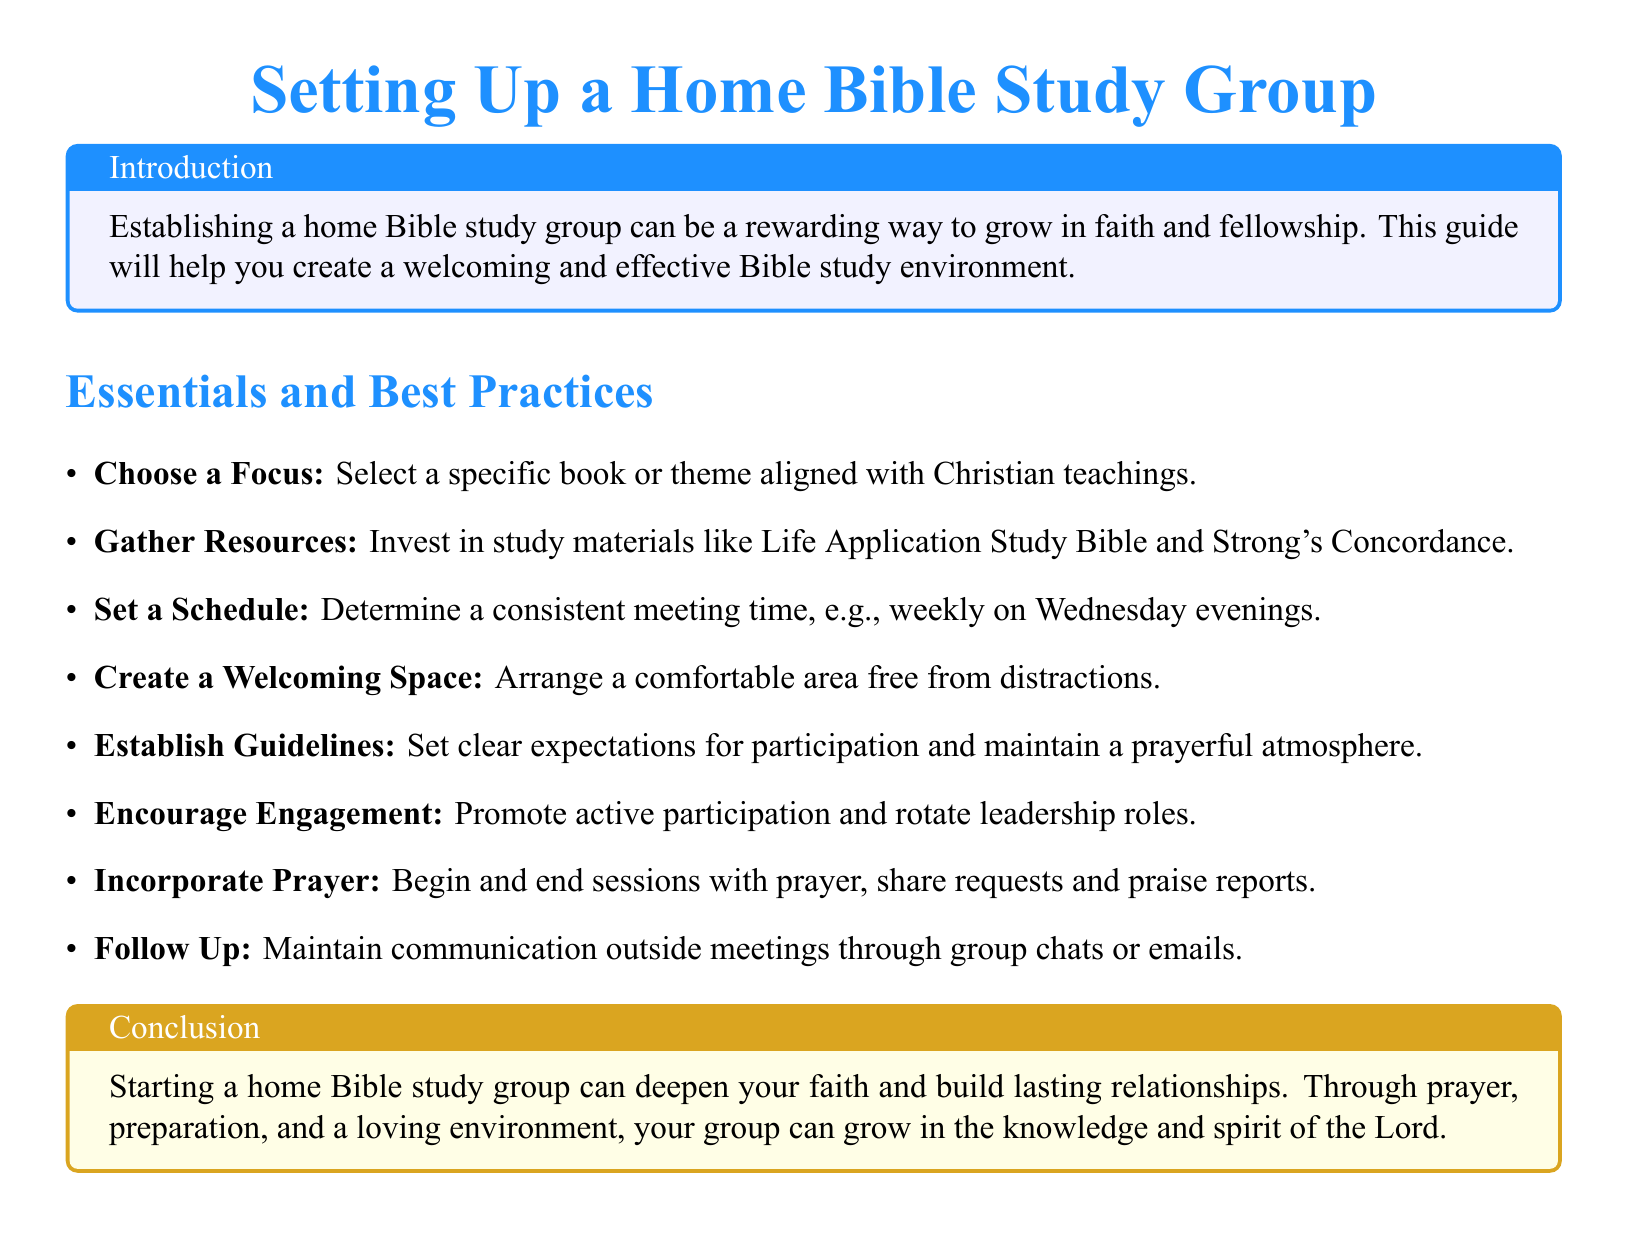What is the main purpose of this document? The document aims to guide readers in creating a home Bible study group that fosters faith and fellowship.
Answer: To help establish a home Bible study group How often should meetings be scheduled? The document suggests having meetings consistently, for instance, once a week on Wednesday evenings.
Answer: Weekly on Wednesday evenings What should be included in the group guidelines? Group guidelines should include clear expectations for participation and maintain a prayerful atmosphere according to the document.
Answer: Participation expectations and prayerful atmosphere What is one resource recommended for the study? The Life Application Study Bible is mentioned as a resource to invest in for the study group.
Answer: Life Application Study Bible What type of atmosphere should the study space have? The document advises that the meeting space should be comfortable and free from distractions.
Answer: Comfortable and free from distractions What should sessions start and end with? According to the guide, sessions should begin and end with prayer.
Answer: Prayer What is a way to maintain communication outside meetings? The document suggests using group chats or emails to keep in contact after meetings.
Answer: Group chats or emails What is the color theme of the title? The title uses a blue color theme in the document.
Answer: Blue What should be promoted during the meetings? The guide emphasizes the importance of encouraging active participation among group members.
Answer: Active participation 